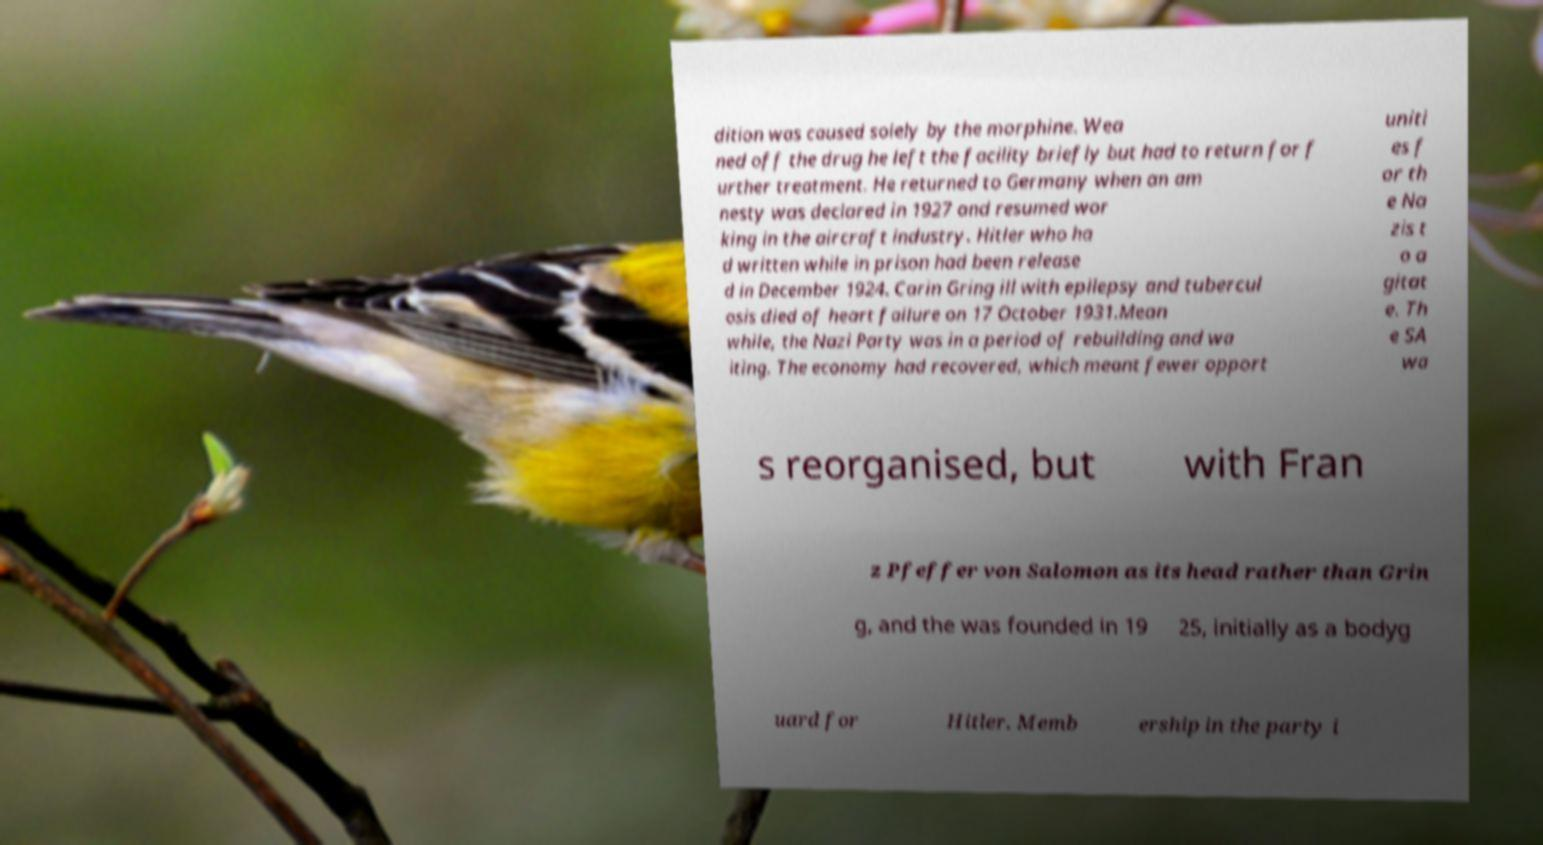For documentation purposes, I need the text within this image transcribed. Could you provide that? dition was caused solely by the morphine. Wea ned off the drug he left the facility briefly but had to return for f urther treatment. He returned to Germany when an am nesty was declared in 1927 and resumed wor king in the aircraft industry. Hitler who ha d written while in prison had been release d in December 1924. Carin Gring ill with epilepsy and tubercul osis died of heart failure on 17 October 1931.Mean while, the Nazi Party was in a period of rebuilding and wa iting. The economy had recovered, which meant fewer opport uniti es f or th e Na zis t o a gitat e. Th e SA wa s reorganised, but with Fran z Pfeffer von Salomon as its head rather than Grin g, and the was founded in 19 25, initially as a bodyg uard for Hitler. Memb ership in the party i 